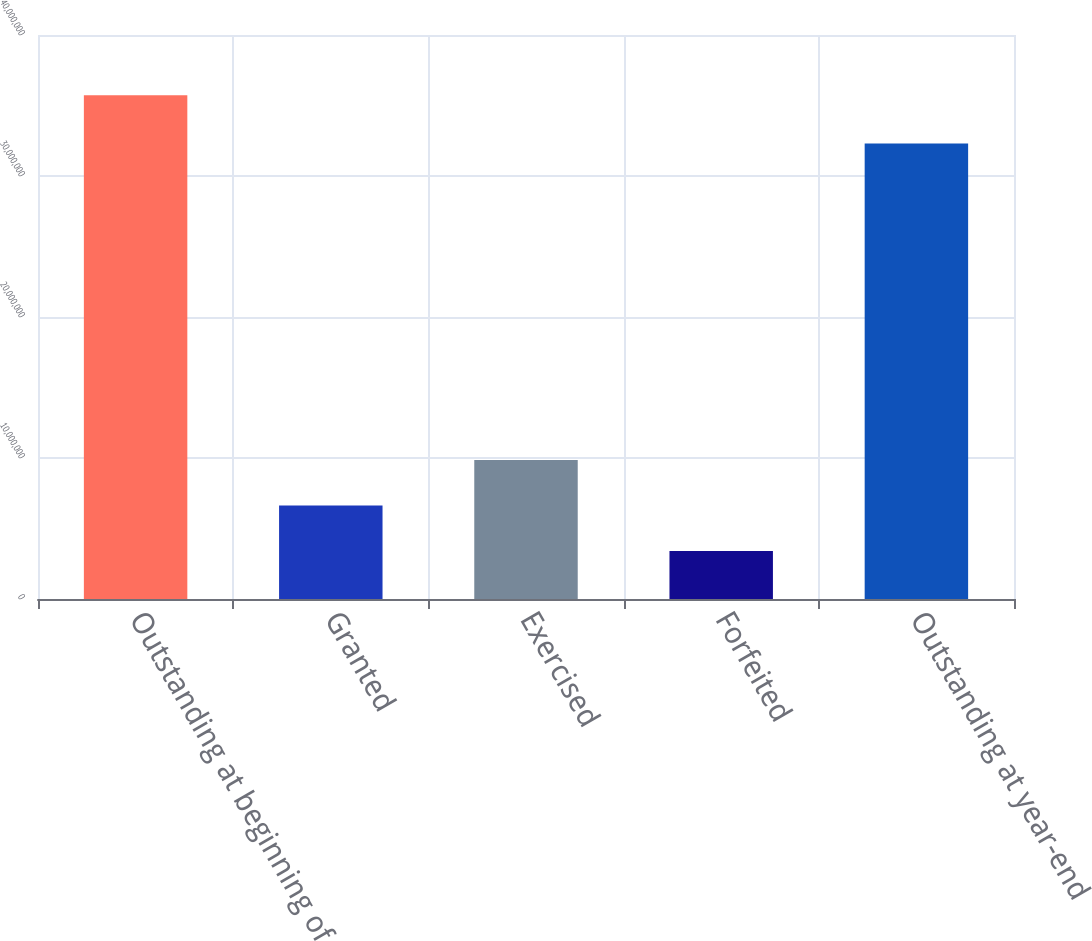Convert chart to OTSL. <chart><loc_0><loc_0><loc_500><loc_500><bar_chart><fcel>Outstanding at beginning of<fcel>Granted<fcel>Exercised<fcel>Forfeited<fcel>Outstanding at year-end<nl><fcel>3.57188e+07<fcel>6.62811e+06<fcel>9.86041e+06<fcel>3.39581e+06<fcel>3.23013e+07<nl></chart> 